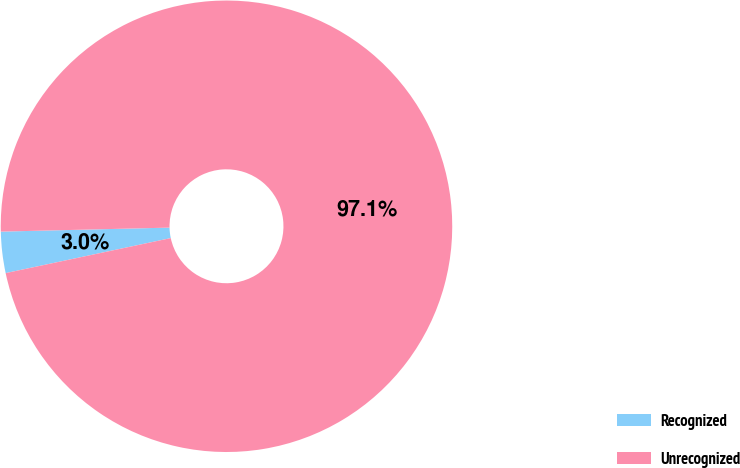Convert chart. <chart><loc_0><loc_0><loc_500><loc_500><pie_chart><fcel>Recognized<fcel>Unrecognized<nl><fcel>2.95%<fcel>97.05%<nl></chart> 